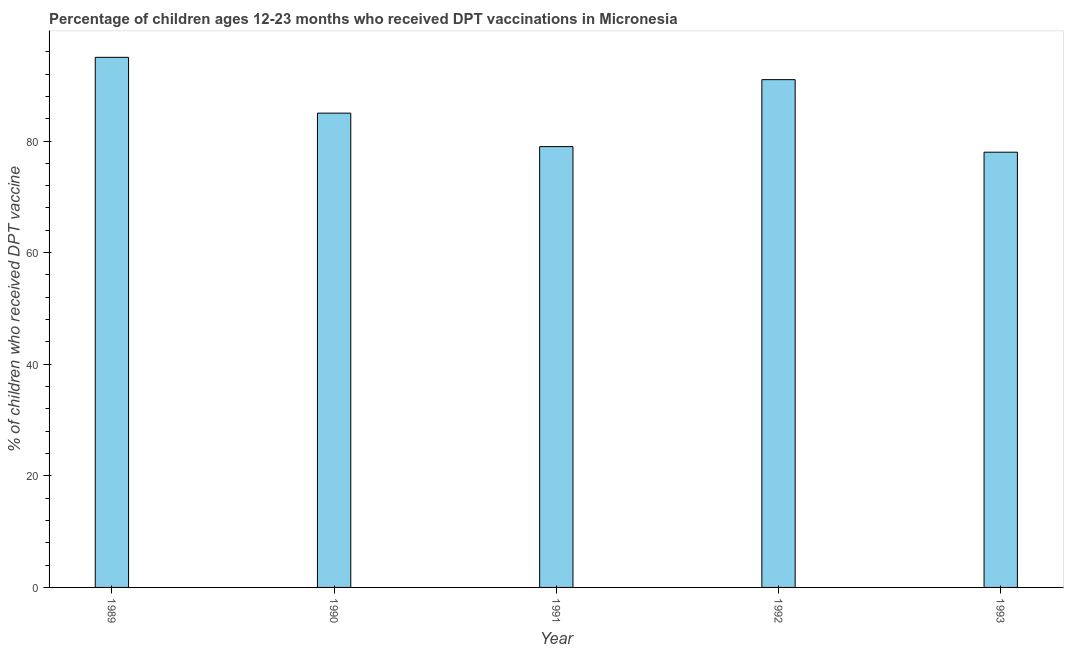What is the title of the graph?
Offer a terse response. Percentage of children ages 12-23 months who received DPT vaccinations in Micronesia. What is the label or title of the X-axis?
Provide a short and direct response. Year. What is the label or title of the Y-axis?
Make the answer very short. % of children who received DPT vaccine. Across all years, what is the maximum percentage of children who received dpt vaccine?
Your answer should be very brief. 95. Across all years, what is the minimum percentage of children who received dpt vaccine?
Your answer should be compact. 78. In which year was the percentage of children who received dpt vaccine maximum?
Your answer should be compact. 1989. In which year was the percentage of children who received dpt vaccine minimum?
Provide a succinct answer. 1993. What is the sum of the percentage of children who received dpt vaccine?
Offer a very short reply. 428. What is the difference between the percentage of children who received dpt vaccine in 1989 and 1992?
Your answer should be compact. 4. What is the median percentage of children who received dpt vaccine?
Offer a very short reply. 85. In how many years, is the percentage of children who received dpt vaccine greater than 8 %?
Your response must be concise. 5. What is the ratio of the percentage of children who received dpt vaccine in 1990 to that in 1993?
Offer a very short reply. 1.09. Is the percentage of children who received dpt vaccine in 1991 less than that in 1993?
Offer a very short reply. No. Is the difference between the percentage of children who received dpt vaccine in 1991 and 1992 greater than the difference between any two years?
Ensure brevity in your answer.  No. What is the difference between the highest and the second highest percentage of children who received dpt vaccine?
Offer a terse response. 4. Is the sum of the percentage of children who received dpt vaccine in 1990 and 1991 greater than the maximum percentage of children who received dpt vaccine across all years?
Your answer should be compact. Yes. What is the difference between the highest and the lowest percentage of children who received dpt vaccine?
Offer a terse response. 17. How many bars are there?
Your answer should be compact. 5. Are all the bars in the graph horizontal?
Ensure brevity in your answer.  No. How many years are there in the graph?
Ensure brevity in your answer.  5. What is the % of children who received DPT vaccine in 1991?
Offer a very short reply. 79. What is the % of children who received DPT vaccine in 1992?
Offer a very short reply. 91. What is the % of children who received DPT vaccine in 1993?
Your answer should be compact. 78. What is the difference between the % of children who received DPT vaccine in 1990 and 1991?
Make the answer very short. 6. What is the difference between the % of children who received DPT vaccine in 1990 and 1993?
Offer a very short reply. 7. What is the ratio of the % of children who received DPT vaccine in 1989 to that in 1990?
Offer a very short reply. 1.12. What is the ratio of the % of children who received DPT vaccine in 1989 to that in 1991?
Your answer should be compact. 1.2. What is the ratio of the % of children who received DPT vaccine in 1989 to that in 1992?
Your answer should be compact. 1.04. What is the ratio of the % of children who received DPT vaccine in 1989 to that in 1993?
Your answer should be very brief. 1.22. What is the ratio of the % of children who received DPT vaccine in 1990 to that in 1991?
Ensure brevity in your answer.  1.08. What is the ratio of the % of children who received DPT vaccine in 1990 to that in 1992?
Your answer should be compact. 0.93. What is the ratio of the % of children who received DPT vaccine in 1990 to that in 1993?
Your answer should be very brief. 1.09. What is the ratio of the % of children who received DPT vaccine in 1991 to that in 1992?
Ensure brevity in your answer.  0.87. What is the ratio of the % of children who received DPT vaccine in 1991 to that in 1993?
Provide a succinct answer. 1.01. What is the ratio of the % of children who received DPT vaccine in 1992 to that in 1993?
Provide a short and direct response. 1.17. 